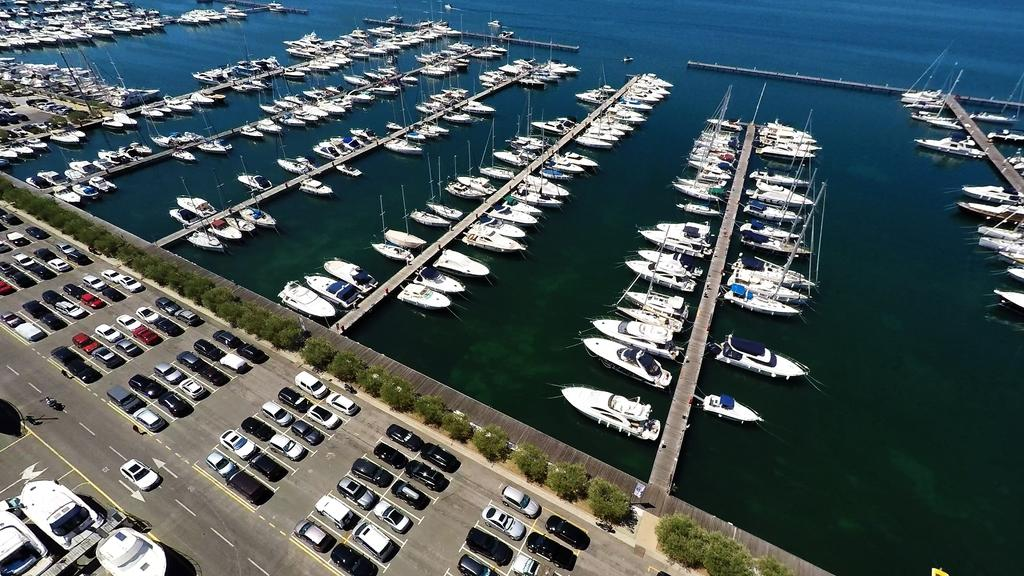What is the main subject of the image? The main subject of the image is a fleet on water. Can you describe the fleet in more detail? Yes, there are decks on water in the image. What type of vegetation is present in the image? There is: There is a group of trees in the image. What can be seen in the background of the image? In the background of the image, there is a group of cars parked in a parking lot. What color is the pet's eye in the image? There is no pet present in the image, so it is not possible to determine the color of its eye. 